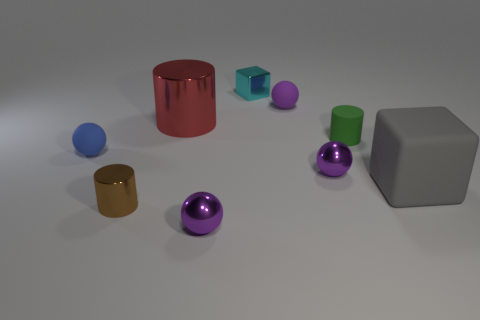The green rubber object that is the same size as the brown metallic cylinder is what shape? The green object, which matches the size of the brown metallic cylinder, is also a cylinder. It appears to be made of a rubber-like material, which differentiates its texture and sheen from the metallic finish of the brown cylinder. 